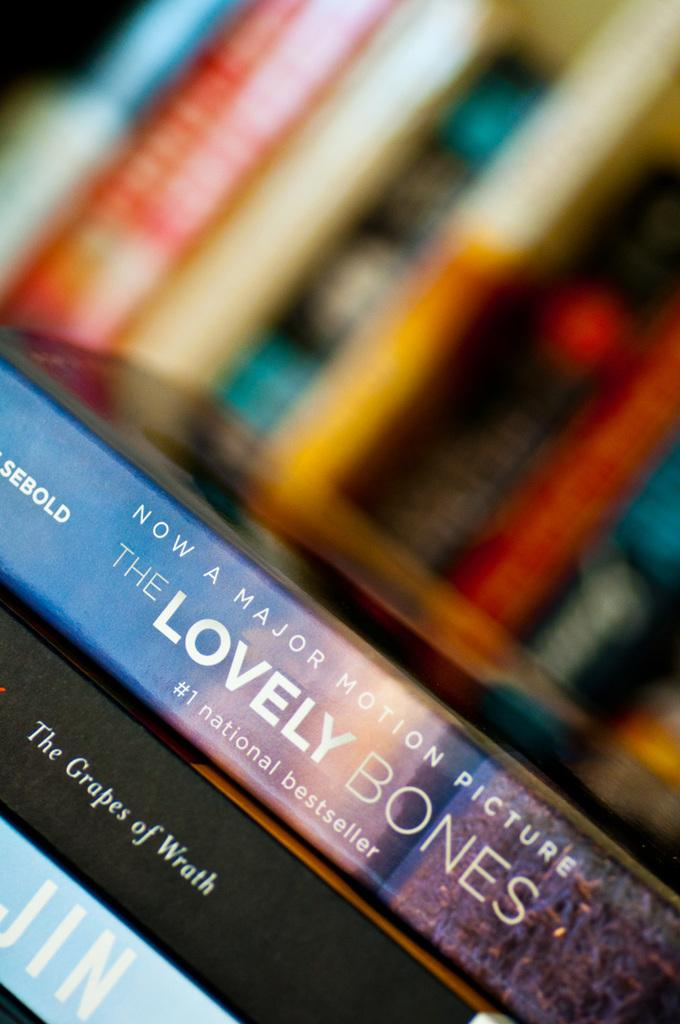<image>
Provide a brief description of the given image. The Lovely Bones is now a major motion picture and it is a national bestseller. 